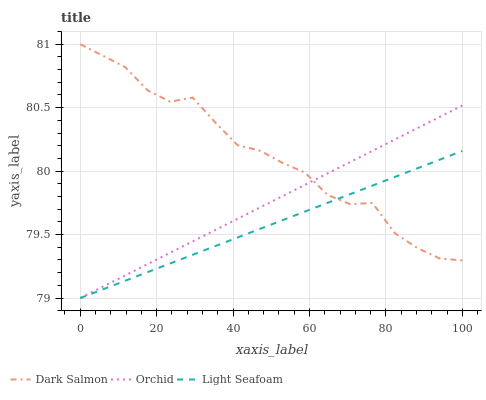Does Light Seafoam have the minimum area under the curve?
Answer yes or no. Yes. Does Dark Salmon have the maximum area under the curve?
Answer yes or no. Yes. Does Orchid have the minimum area under the curve?
Answer yes or no. No. Does Orchid have the maximum area under the curve?
Answer yes or no. No. Is Orchid the smoothest?
Answer yes or no. Yes. Is Dark Salmon the roughest?
Answer yes or no. Yes. Is Dark Salmon the smoothest?
Answer yes or no. No. Is Orchid the roughest?
Answer yes or no. No. Does Light Seafoam have the lowest value?
Answer yes or no. Yes. Does Dark Salmon have the lowest value?
Answer yes or no. No. Does Dark Salmon have the highest value?
Answer yes or no. Yes. Does Orchid have the highest value?
Answer yes or no. No. Does Orchid intersect Light Seafoam?
Answer yes or no. Yes. Is Orchid less than Light Seafoam?
Answer yes or no. No. Is Orchid greater than Light Seafoam?
Answer yes or no. No. 